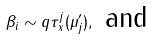<formula> <loc_0><loc_0><loc_500><loc_500>\beta _ { i } \sim q \tau _ { x } ^ { j } ( \mu ^ { \prime } _ { j } ) , \text { and }</formula> 